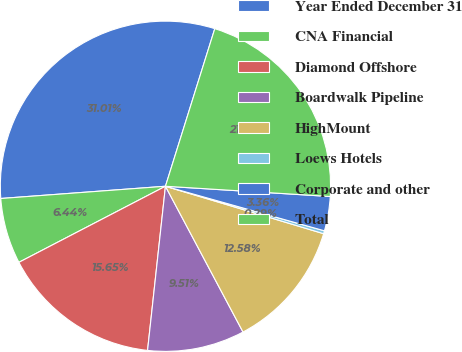Convert chart to OTSL. <chart><loc_0><loc_0><loc_500><loc_500><pie_chart><fcel>Year Ended December 31<fcel>CNA Financial<fcel>Diamond Offshore<fcel>Boardwalk Pipeline<fcel>HighMount<fcel>Loews Hotels<fcel>Corporate and other<fcel>Total<nl><fcel>31.01%<fcel>6.44%<fcel>15.65%<fcel>9.51%<fcel>12.58%<fcel>0.29%<fcel>3.36%<fcel>21.16%<nl></chart> 